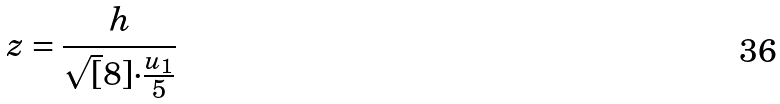<formula> <loc_0><loc_0><loc_500><loc_500>z = \frac { h } { \sqrt { [ } 8 ] { \cdot \frac { u _ { 1 } } { 5 } } }</formula> 